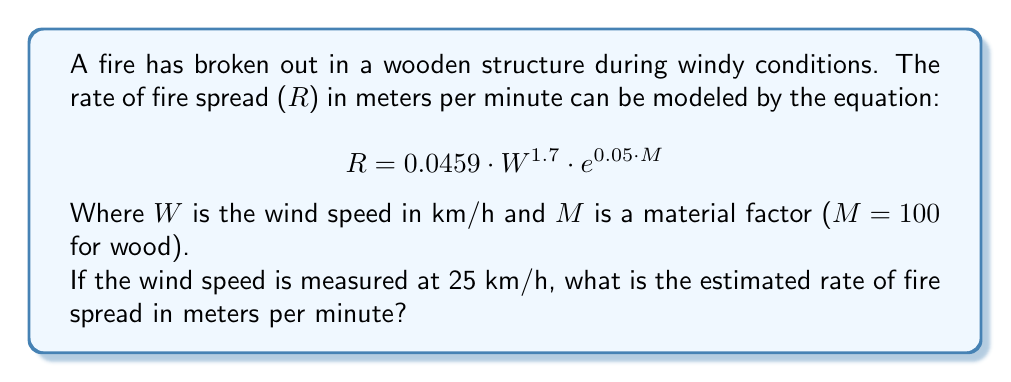Can you answer this question? To solve this problem, we need to follow these steps:

1. Identify the given values:
   - Wind speed (W) = 25 km/h
   - Material factor (M) = 100 (for wood)

2. Substitute these values into the equation:
   $$R = 0.0459 \cdot W^{1.7} \cdot e^{0.05 \cdot M}$$

3. Calculate $W^{1.7}$:
   $$25^{1.7} \approx 245.7418$$

4. Calculate $e^{0.05 \cdot M}$:
   $$e^{0.05 \cdot 100} = e^5 \approx 148.4132$$

5. Multiply all factors:
   $$R = 0.0459 \cdot 245.7418 \cdot 148.4132$$

6. Compute the final result:
   $$R \approx 1674.8367$$

Therefore, the estimated rate of fire spread is approximately 1674.84 meters per minute.
Answer: 1674.84 meters per minute 